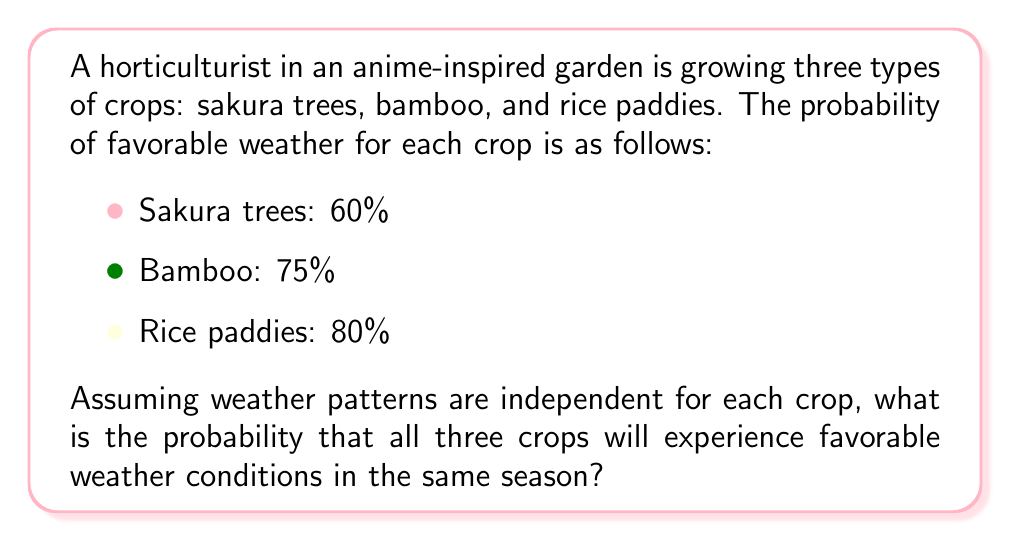Give your solution to this math problem. To solve this problem, we need to use the multiplication rule of probability for independent events. Since the weather patterns are assumed to be independent for each crop, we can multiply the individual probabilities to find the probability of all events occurring simultaneously.

Let's define our events:
$S$: Favorable weather for Sakura trees
$B$: Favorable weather for Bamboo
$R$: Favorable weather for Rice paddies

We're given:
$P(S) = 0.60$
$P(B) = 0.75$
$P(R) = 0.80$

The probability of all three crops experiencing favorable weather is:

$$P(S \cap B \cap R) = P(S) \times P(B) \times P(R)$$

Substituting the values:

$$P(S \cap B \cap R) = 0.60 \times 0.75 \times 0.80$$

Calculating:

$$P(S \cap B \cap R) = 0.36$$

To convert to a percentage, we multiply by 100:

$$0.36 \times 100 = 36\%$$
Answer: The probability that all three crops will experience favorable weather conditions in the same season is 36% or 0.36. 